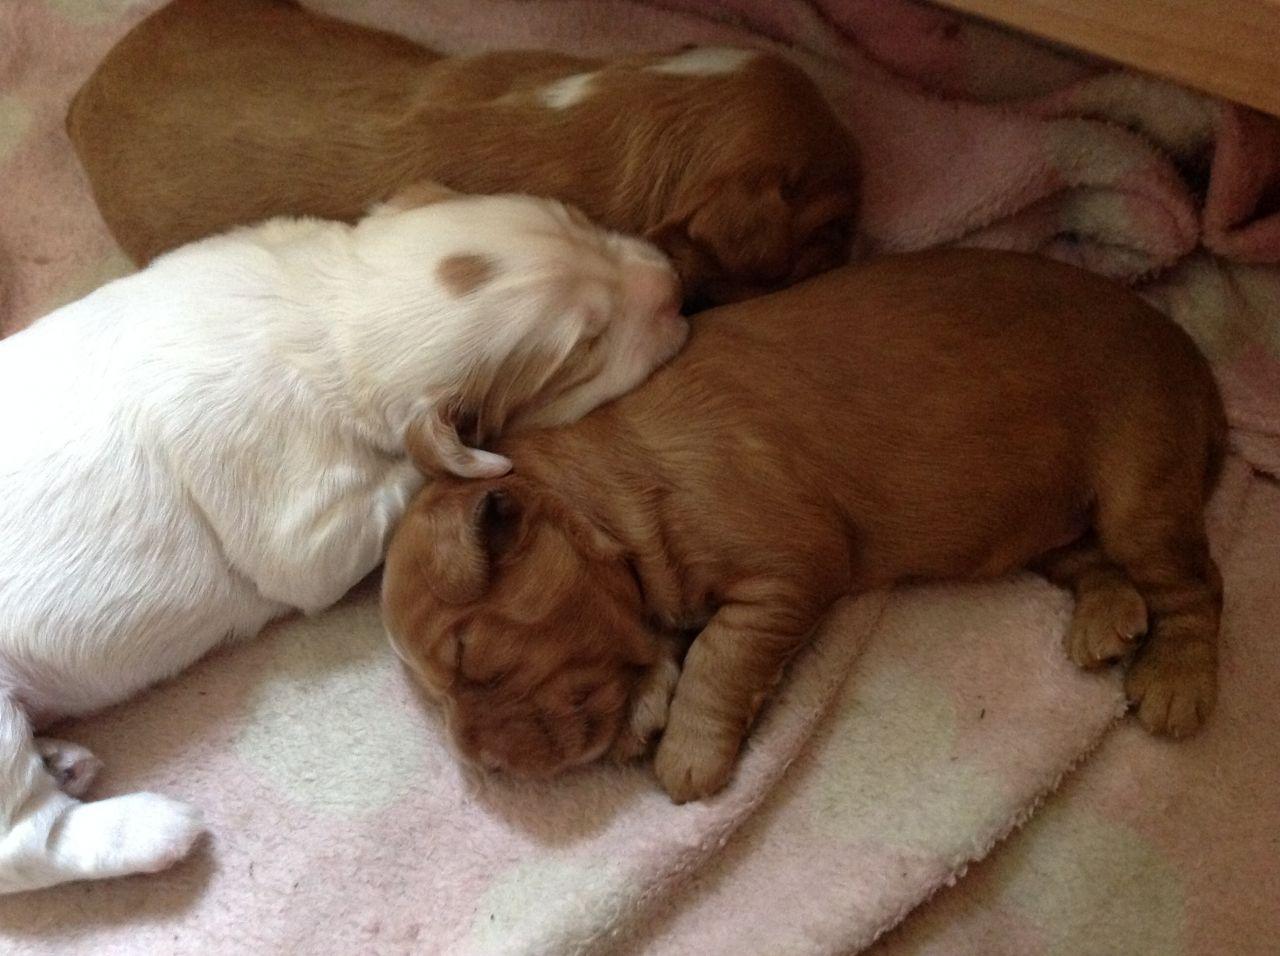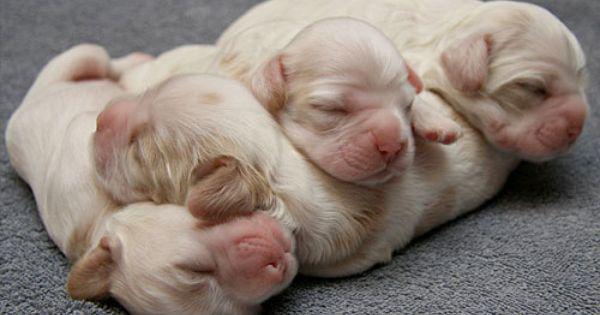The first image is the image on the left, the second image is the image on the right. Analyze the images presented: Is the assertion "There are two dogs in the lefthand image." valid? Answer yes or no. No. The first image is the image on the left, the second image is the image on the right. Assess this claim about the two images: "All of the pups are sleeping.". Correct or not? Answer yes or no. Yes. 